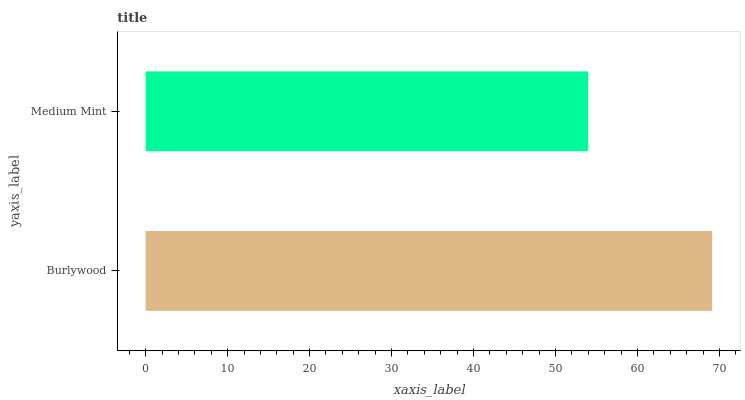Is Medium Mint the minimum?
Answer yes or no. Yes. Is Burlywood the maximum?
Answer yes or no. Yes. Is Medium Mint the maximum?
Answer yes or no. No. Is Burlywood greater than Medium Mint?
Answer yes or no. Yes. Is Medium Mint less than Burlywood?
Answer yes or no. Yes. Is Medium Mint greater than Burlywood?
Answer yes or no. No. Is Burlywood less than Medium Mint?
Answer yes or no. No. Is Burlywood the high median?
Answer yes or no. Yes. Is Medium Mint the low median?
Answer yes or no. Yes. Is Medium Mint the high median?
Answer yes or no. No. Is Burlywood the low median?
Answer yes or no. No. 